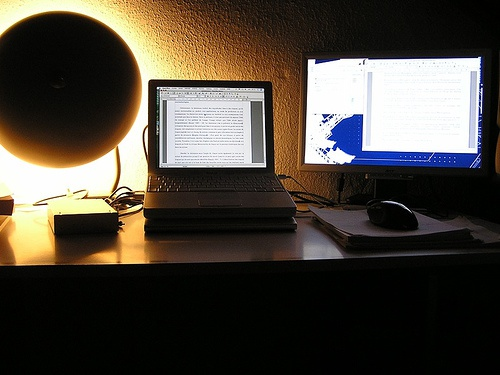Describe the objects in this image and their specific colors. I can see tv in khaki, white, black, darkblue, and navy tones, laptop in khaki, black, lightgray, darkgray, and gray tones, book in khaki, black, and gray tones, and mouse in khaki, black, gray, darkgray, and lavender tones in this image. 